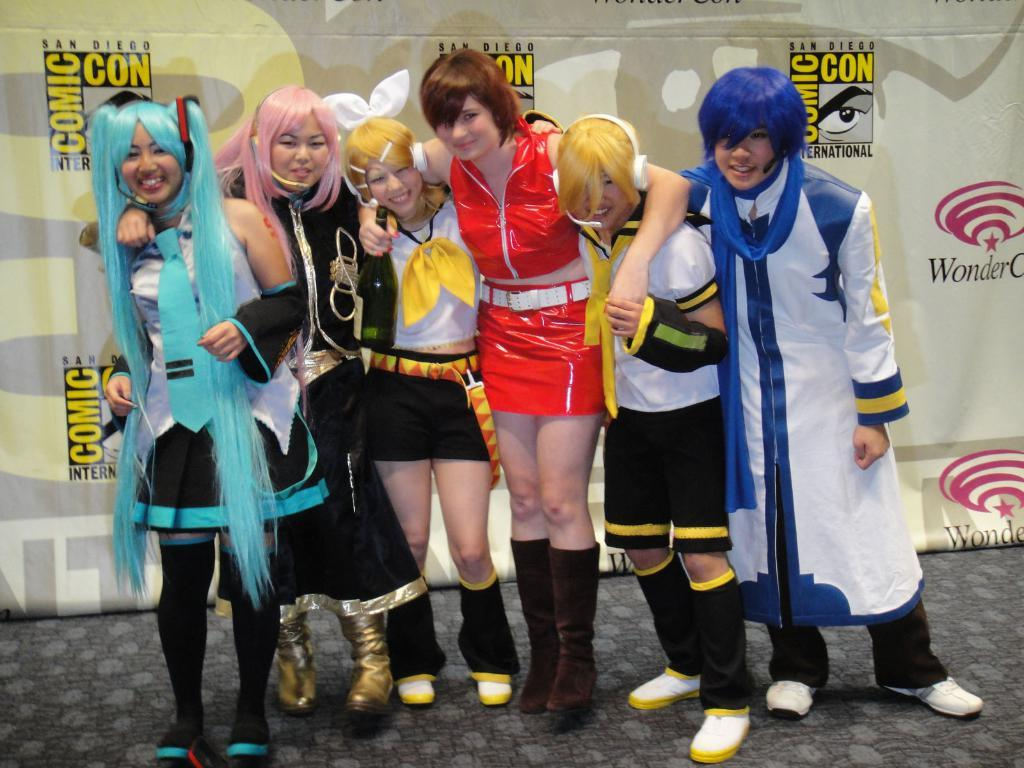<image>
Write a terse but informative summary of the picture. a comic con poster behind the people together 